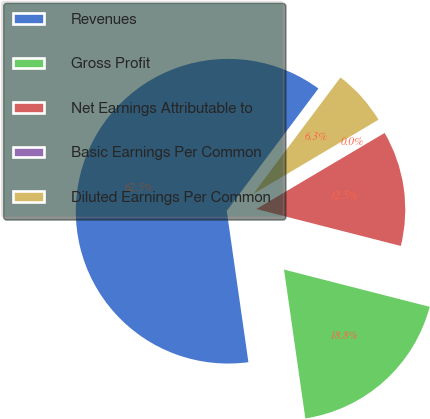<chart> <loc_0><loc_0><loc_500><loc_500><pie_chart><fcel>Revenues<fcel>Gross Profit<fcel>Net Earnings Attributable to<fcel>Basic Earnings Per Common<fcel>Diluted Earnings Per Common<nl><fcel>62.49%<fcel>18.75%<fcel>12.5%<fcel>0.0%<fcel>6.25%<nl></chart> 